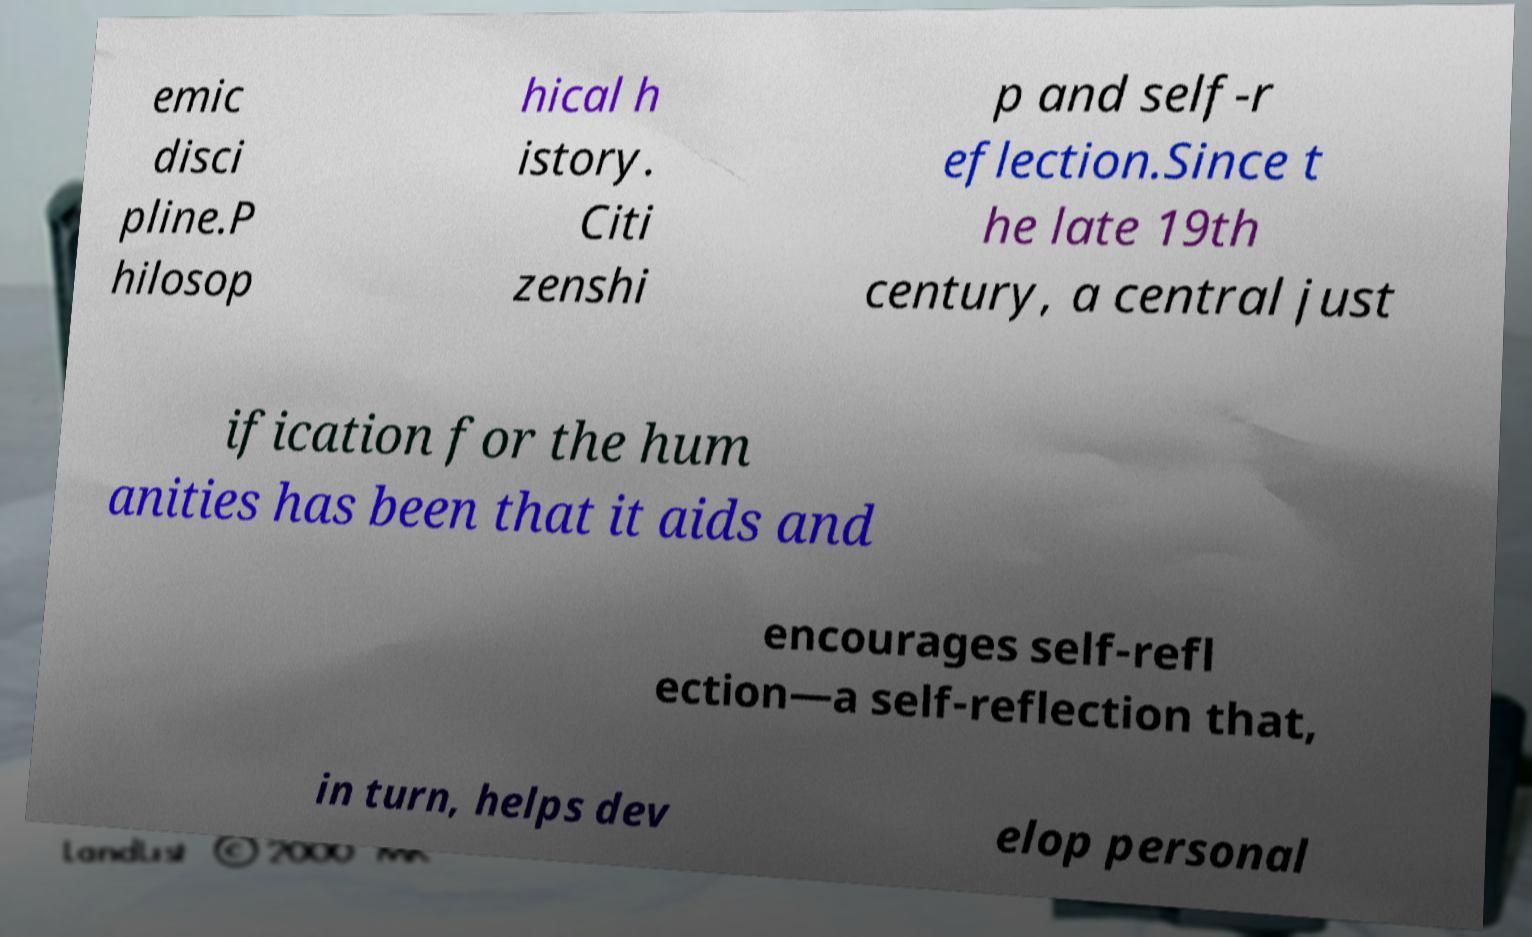There's text embedded in this image that I need extracted. Can you transcribe it verbatim? emic disci pline.P hilosop hical h istory. Citi zenshi p and self-r eflection.Since t he late 19th century, a central just ification for the hum anities has been that it aids and encourages self-refl ection—a self-reflection that, in turn, helps dev elop personal 